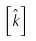<formula> <loc_0><loc_0><loc_500><loc_500>\left [ \hat { k } \right ]</formula> 